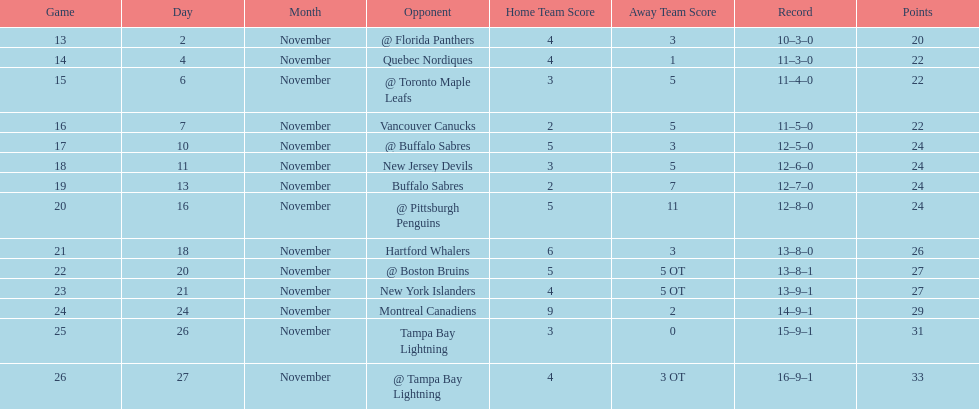What was the total penalty minutes that dave brown had on the 1993-1994 flyers? 137. 